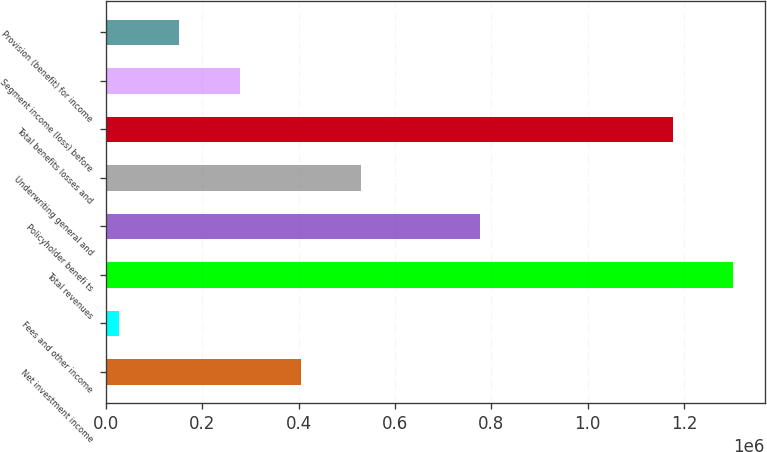Convert chart to OTSL. <chart><loc_0><loc_0><loc_500><loc_500><bar_chart><fcel>Net investment income<fcel>Fees and other income<fcel>Total revenues<fcel>Policyholder benefi ts<fcel>Underwriting general and<fcel>Total benefits losses and<fcel>Segment income (loss) before<fcel>Provision (benefit) for income<nl><fcel>403772<fcel>26139<fcel>1.30238e+06<fcel>775684<fcel>529649<fcel>1.1765e+06<fcel>277894<fcel>152016<nl></chart> 